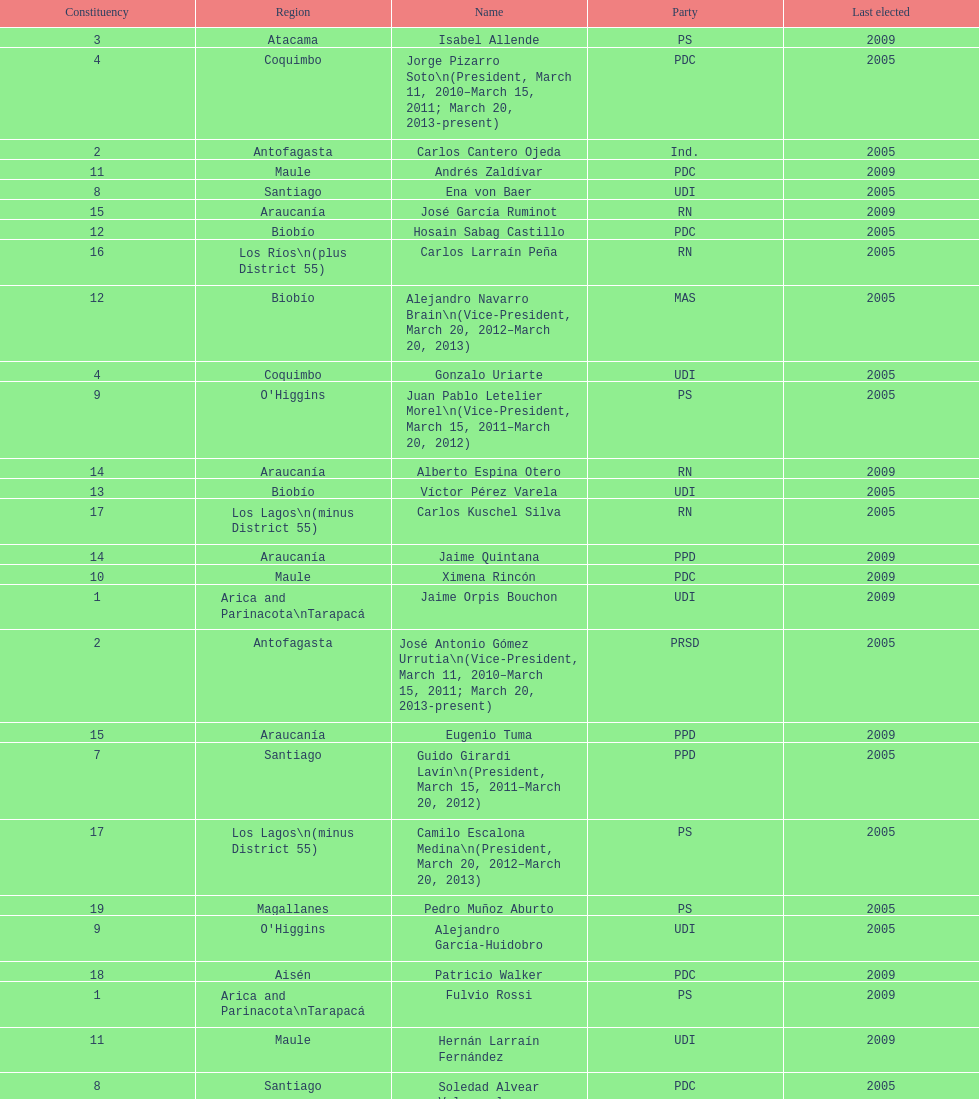Who was not last elected in either 2005 or 2009? Antonio Horvath Kiss. 